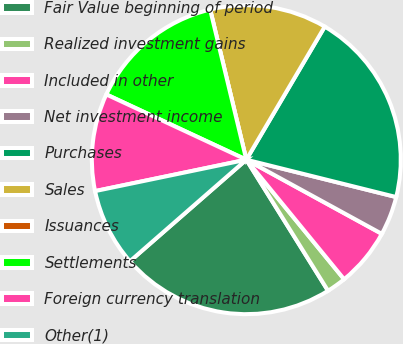Convert chart to OTSL. <chart><loc_0><loc_0><loc_500><loc_500><pie_chart><fcel>Fair Value beginning of period<fcel>Realized investment gains<fcel>Included in other<fcel>Net investment income<fcel>Purchases<fcel>Sales<fcel>Issuances<fcel>Settlements<fcel>Foreign currency translation<fcel>Other(1)<nl><fcel>22.45%<fcel>2.04%<fcel>6.12%<fcel>4.08%<fcel>20.41%<fcel>12.24%<fcel>0.0%<fcel>14.29%<fcel>10.2%<fcel>8.16%<nl></chart> 